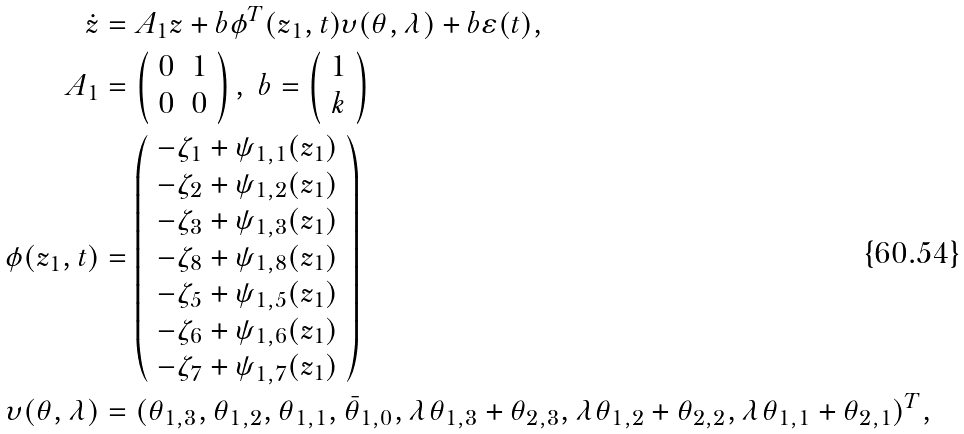Convert formula to latex. <formula><loc_0><loc_0><loc_500><loc_500>\dot { z } & = A _ { 1 } z + b \phi ^ { T } ( z _ { 1 } , t ) { \upsilon } ( \theta , \lambda ) + b \varepsilon ( t ) , \\ A _ { 1 } & = \left ( \begin{array} { c c } 0 & 1 \\ 0 & 0 \end{array} \right ) , \ b = \left ( \begin{array} { c } 1 \\ k \end{array} \right ) \\ \phi ( z _ { 1 } , t ) & = \left ( \begin{array} { c } - \zeta _ { 1 } + \psi _ { 1 , 1 } ( z _ { 1 } ) \\ - \zeta _ { 2 } + \psi _ { 1 , 2 } ( z _ { 1 } ) \\ - \zeta _ { 3 } + \psi _ { 1 , 3 } ( z _ { 1 } ) \\ - \zeta _ { 8 } + \psi _ { 1 , 8 } ( z _ { 1 } ) \\ - \zeta _ { 5 } + \psi _ { 1 , 5 } ( z _ { 1 } ) \\ - \zeta _ { 6 } + \psi _ { 1 , 6 } ( z _ { 1 } ) \\ - \zeta _ { 7 } + \psi _ { 1 , 7 } ( z _ { 1 } ) \\ \end{array} \right ) \\ { \upsilon } ( \theta , \lambda ) & = ( \theta _ { 1 , 3 } , \theta _ { 1 , 2 } , \theta _ { 1 , 1 } , \bar { \theta } _ { 1 , 0 } , \lambda \theta _ { 1 , 3 } + \theta _ { 2 , 3 } , \lambda \theta _ { 1 , 2 } + \theta _ { 2 , 2 } , \lambda \theta _ { 1 , 1 } + \theta _ { 2 , 1 } ) ^ { T } ,</formula> 